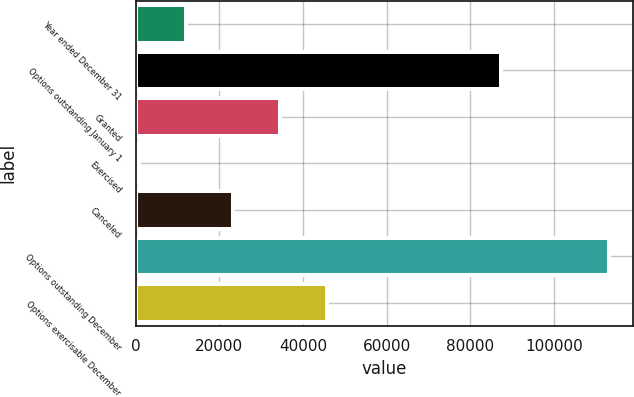Convert chart. <chart><loc_0><loc_0><loc_500><loc_500><bar_chart><fcel>Year ended December 31<fcel>Options outstanding January 1<fcel>Granted<fcel>Exercised<fcel>Canceled<fcel>Options outstanding December<fcel>Options exercisable December<nl><fcel>11922.1<fcel>87393<fcel>34418.3<fcel>674<fcel>23170.2<fcel>113155<fcel>45666.4<nl></chart> 